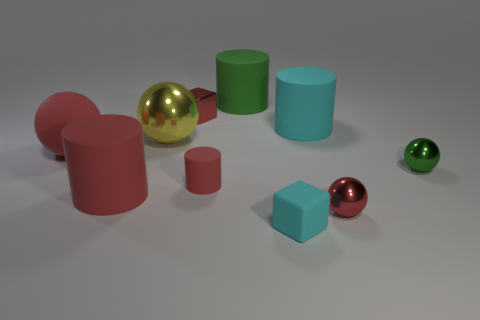There is a tiny cylinder that is the same color as the large rubber sphere; what is its material?
Ensure brevity in your answer.  Rubber. What number of tiny objects are there?
Your answer should be compact. 5. Is there a tiny sphere that has the same material as the big yellow thing?
Your answer should be very brief. Yes. There is a metal object that is the same color as the shiny block; what is its size?
Your answer should be very brief. Small. There is a red matte cylinder right of the red cube; does it have the same size as the ball that is right of the red shiny ball?
Provide a succinct answer. Yes. How big is the green thing that is in front of the big cyan cylinder?
Offer a very short reply. Small. Is there a tiny rubber object of the same color as the matte block?
Ensure brevity in your answer.  No. There is a cylinder that is behind the red shiny cube; is there a yellow metallic thing on the right side of it?
Your answer should be very brief. No. There is a rubber sphere; is its size the same as the red matte cylinder on the right side of the small red cube?
Make the answer very short. No. Is there a cyan matte cube that is on the right side of the tiny sphere behind the ball that is in front of the small green shiny ball?
Your answer should be very brief. No. 